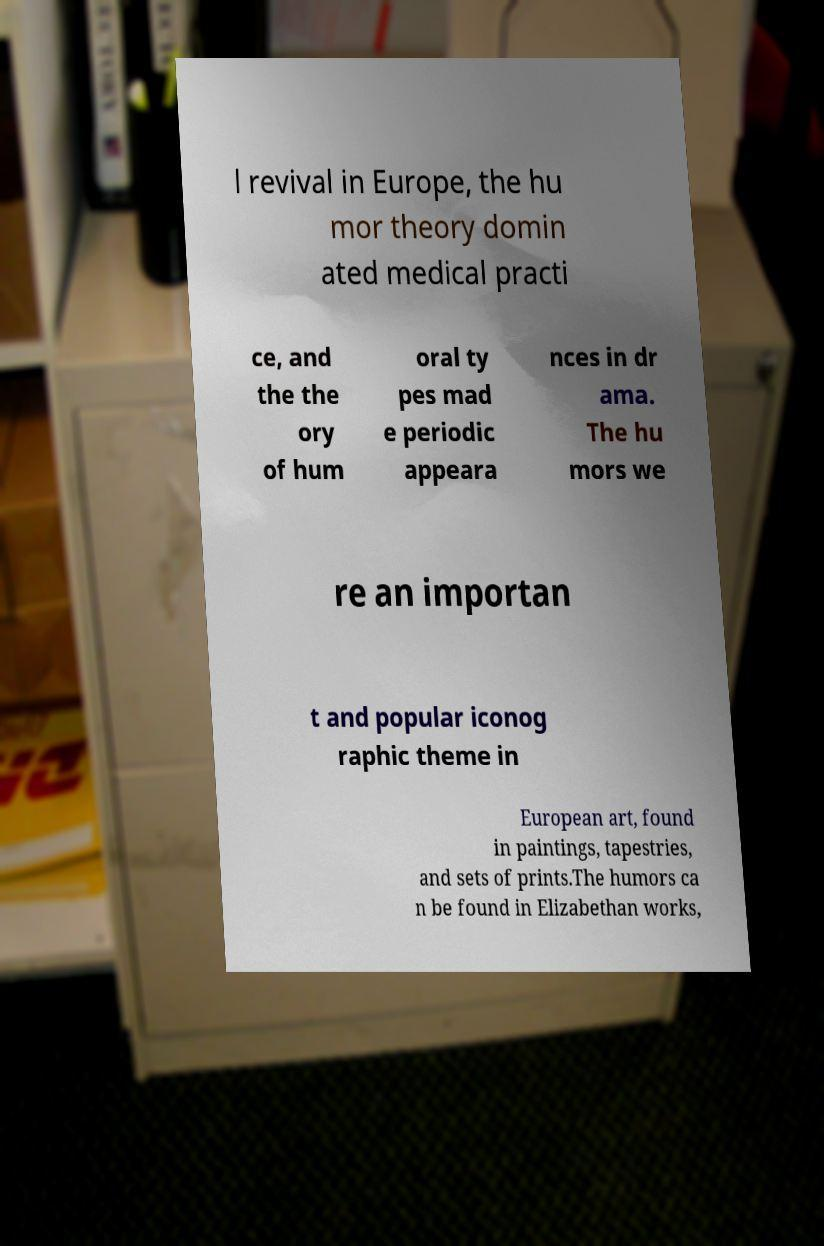What messages or text are displayed in this image? I need them in a readable, typed format. l revival in Europe, the hu mor theory domin ated medical practi ce, and the the ory of hum oral ty pes mad e periodic appeara nces in dr ama. The hu mors we re an importan t and popular iconog raphic theme in European art, found in paintings, tapestries, and sets of prints.The humors ca n be found in Elizabethan works, 